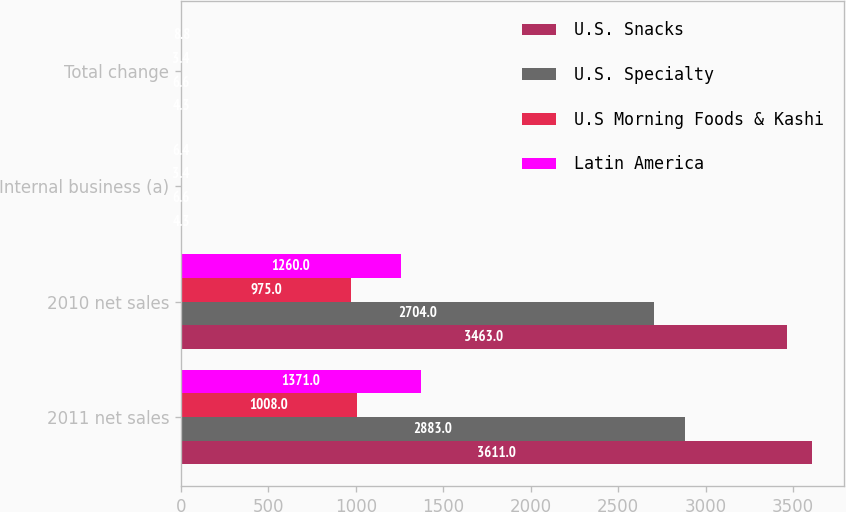Convert chart. <chart><loc_0><loc_0><loc_500><loc_500><stacked_bar_chart><ecel><fcel>2011 net sales<fcel>2010 net sales<fcel>Internal business (a)<fcel>Total change<nl><fcel>U.S. Snacks<fcel>3611<fcel>3463<fcel>4.3<fcel>4.3<nl><fcel>U.S. Specialty<fcel>2883<fcel>2704<fcel>6.6<fcel>6.6<nl><fcel>U.S Morning Foods & Kashi<fcel>1008<fcel>975<fcel>3.4<fcel>3.4<nl><fcel>Latin America<fcel>1371<fcel>1260<fcel>6.4<fcel>8.8<nl></chart> 